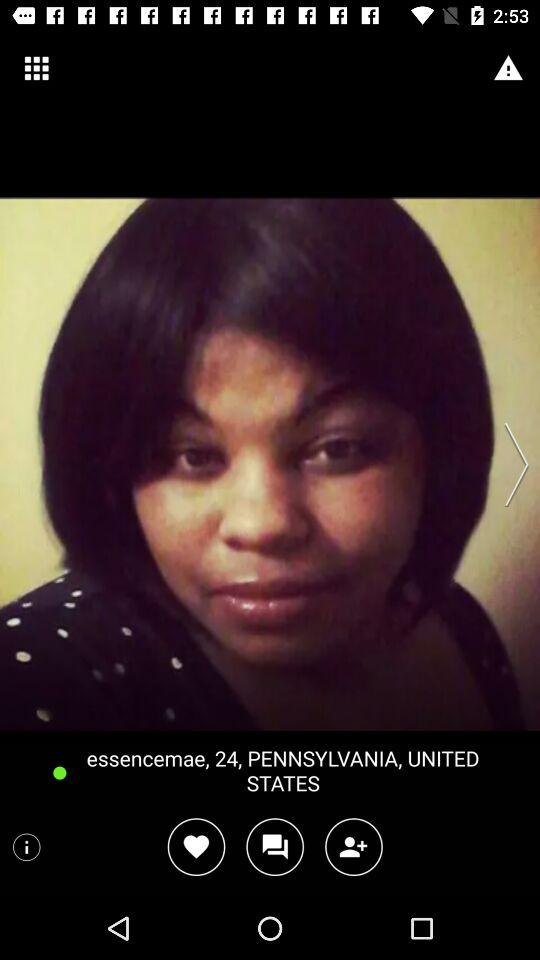What location is given? The given location is Pennsylvania, United States. 